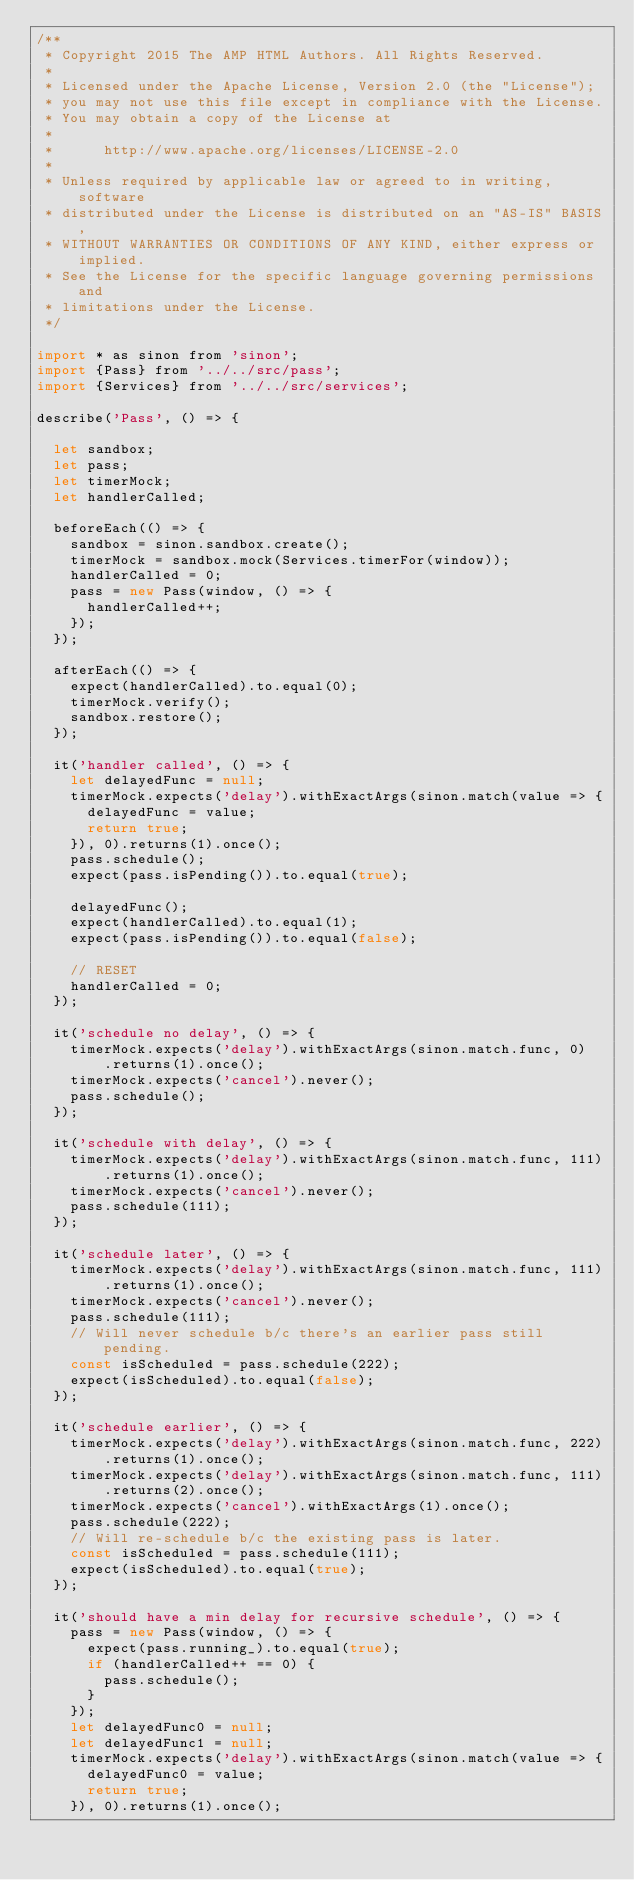Convert code to text. <code><loc_0><loc_0><loc_500><loc_500><_JavaScript_>/**
 * Copyright 2015 The AMP HTML Authors. All Rights Reserved.
 *
 * Licensed under the Apache License, Version 2.0 (the "License");
 * you may not use this file except in compliance with the License.
 * You may obtain a copy of the License at
 *
 *      http://www.apache.org/licenses/LICENSE-2.0
 *
 * Unless required by applicable law or agreed to in writing, software
 * distributed under the License is distributed on an "AS-IS" BASIS,
 * WITHOUT WARRANTIES OR CONDITIONS OF ANY KIND, either express or implied.
 * See the License for the specific language governing permissions and
 * limitations under the License.
 */

import * as sinon from 'sinon';
import {Pass} from '../../src/pass';
import {Services} from '../../src/services';

describe('Pass', () => {

  let sandbox;
  let pass;
  let timerMock;
  let handlerCalled;

  beforeEach(() => {
    sandbox = sinon.sandbox.create();
    timerMock = sandbox.mock(Services.timerFor(window));
    handlerCalled = 0;
    pass = new Pass(window, () => {
      handlerCalled++;
    });
  });

  afterEach(() => {
    expect(handlerCalled).to.equal(0);
    timerMock.verify();
    sandbox.restore();
  });

  it('handler called', () => {
    let delayedFunc = null;
    timerMock.expects('delay').withExactArgs(sinon.match(value => {
      delayedFunc = value;
      return true;
    }), 0).returns(1).once();
    pass.schedule();
    expect(pass.isPending()).to.equal(true);

    delayedFunc();
    expect(handlerCalled).to.equal(1);
    expect(pass.isPending()).to.equal(false);

    // RESET
    handlerCalled = 0;
  });

  it('schedule no delay', () => {
    timerMock.expects('delay').withExactArgs(sinon.match.func, 0)
        .returns(1).once();
    timerMock.expects('cancel').never();
    pass.schedule();
  });

  it('schedule with delay', () => {
    timerMock.expects('delay').withExactArgs(sinon.match.func, 111)
        .returns(1).once();
    timerMock.expects('cancel').never();
    pass.schedule(111);
  });

  it('schedule later', () => {
    timerMock.expects('delay').withExactArgs(sinon.match.func, 111)
        .returns(1).once();
    timerMock.expects('cancel').never();
    pass.schedule(111);
    // Will never schedule b/c there's an earlier pass still pending.
    const isScheduled = pass.schedule(222);
    expect(isScheduled).to.equal(false);
  });

  it('schedule earlier', () => {
    timerMock.expects('delay').withExactArgs(sinon.match.func, 222)
        .returns(1).once();
    timerMock.expects('delay').withExactArgs(sinon.match.func, 111)
        .returns(2).once();
    timerMock.expects('cancel').withExactArgs(1).once();
    pass.schedule(222);
    // Will re-schedule b/c the existing pass is later.
    const isScheduled = pass.schedule(111);
    expect(isScheduled).to.equal(true);
  });

  it('should have a min delay for recursive schedule', () => {
    pass = new Pass(window, () => {
      expect(pass.running_).to.equal(true);
      if (handlerCalled++ == 0) {
        pass.schedule();
      }
    });
    let delayedFunc0 = null;
    let delayedFunc1 = null;
    timerMock.expects('delay').withExactArgs(sinon.match(value => {
      delayedFunc0 = value;
      return true;
    }), 0).returns(1).once();</code> 